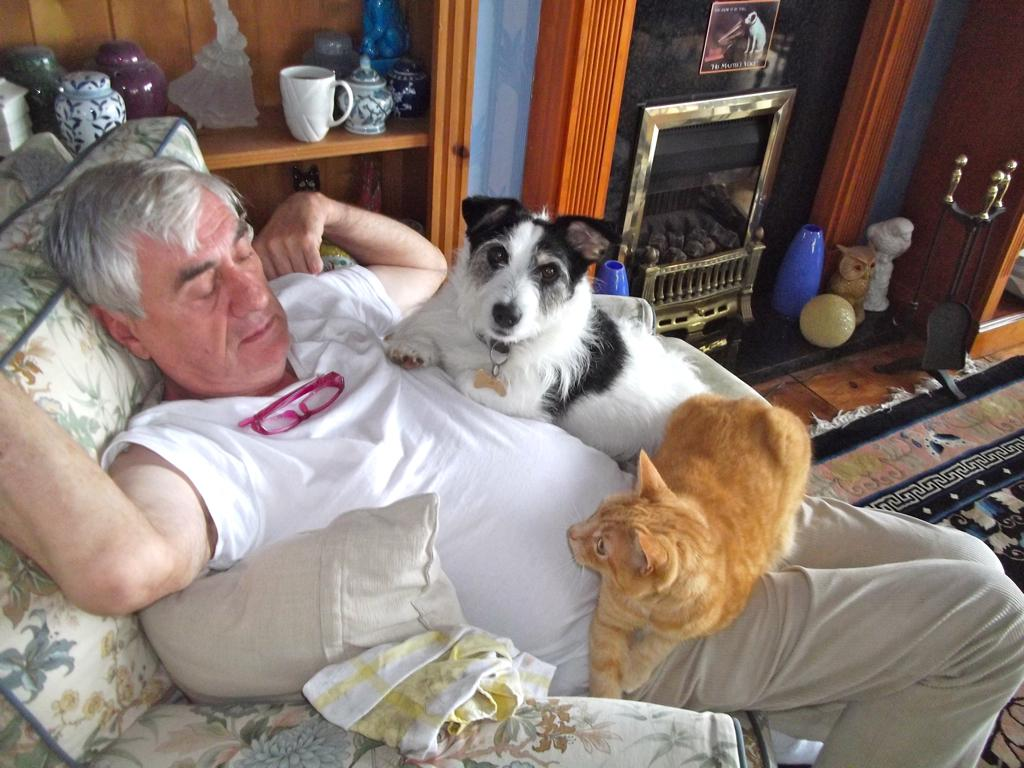Who is present in the image? There is a man in the image. What is the man doing in the image? The man is sitting on a sofa. Are there any animals in the image? Yes, there is a cat and a dog on the man. What can be seen on the shelf in the image? There are items placed on a shelf in the image. What type of honey is the man using to lick the dog's tongue in the image? There is no honey or dog's tongue visible in the image, and the man is not performing any such action. 